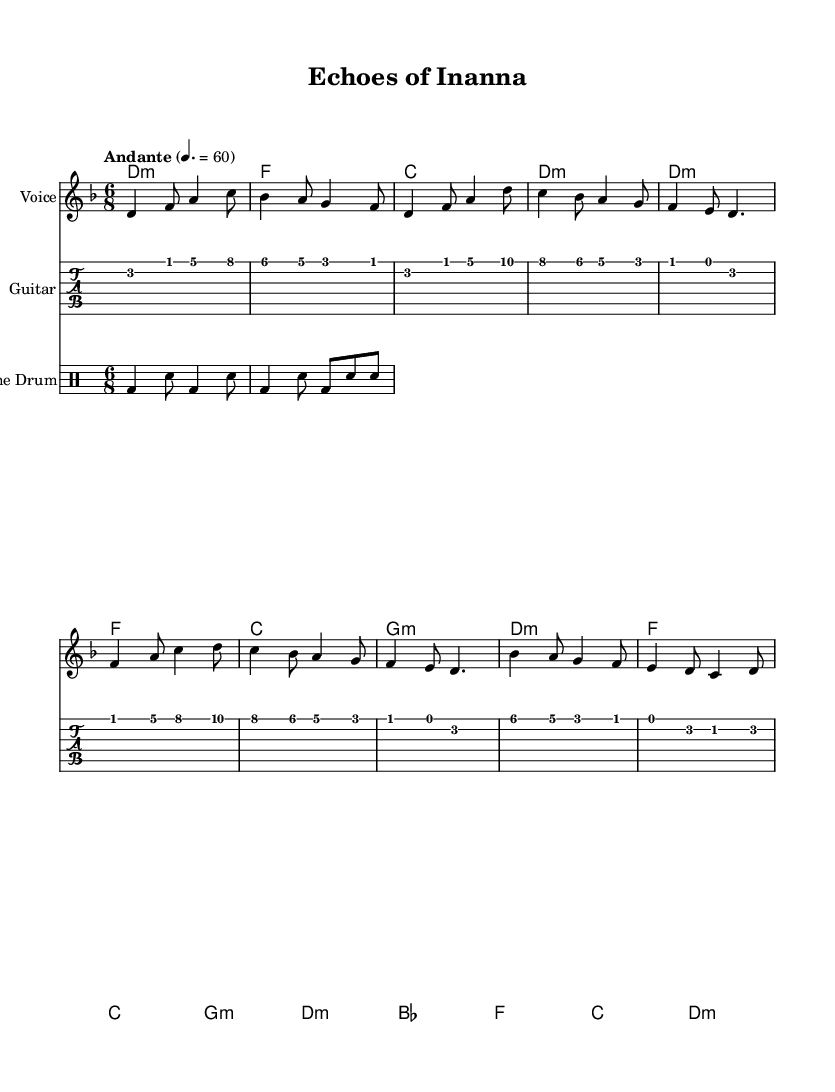What is the key signature of this music? The key signature is indicated by 'd' with a flat symbol, which means it has one flat note (C). Since the music is in d minor, which has the same key signature as F major, there are no sharps or flats notated beyond the key signature.
Answer: d minor What is the time signature of this piece? The time signature is shown at the beginning of the score, represented by 6 over 8. This indicates that there are six eighth notes per measure.
Answer: 6/8 What is the tempo marking of the music? The tempo marking is noted as "Andante," which is a common musical term indicating a moderate pace. The metronome marking is also provided as 60, suggesting 60 beats per minute.
Answer: Andante How many measures are in the chorus? By counting the measures in the chorus section, which is specified in the structure of the music, we see it consists of four distinct measures, each contributing to the overall musical development.
Answer: 4 What is the first note of the melody? The first note in the melody starts at a D note, as symbolized in the score at the beginning of the melody section. This note establishes the tonal center of the piece.
Answer: D What type of drum is used in this score? The score includes a specific staff labeled "Frame Drum," indicating the type of percussion instrument that will accompany the melody. The rhythmic patterns are tailored for that instrument.
Answer: Frame Drum What is the harmonic structure of the verse's first measure? The first measure of the verse encompasses the chord progression highlighted with the d minor chord, establishing the foundational harmony for this section. This initial harmony sets the mood for the verses that follow.
Answer: d minor 